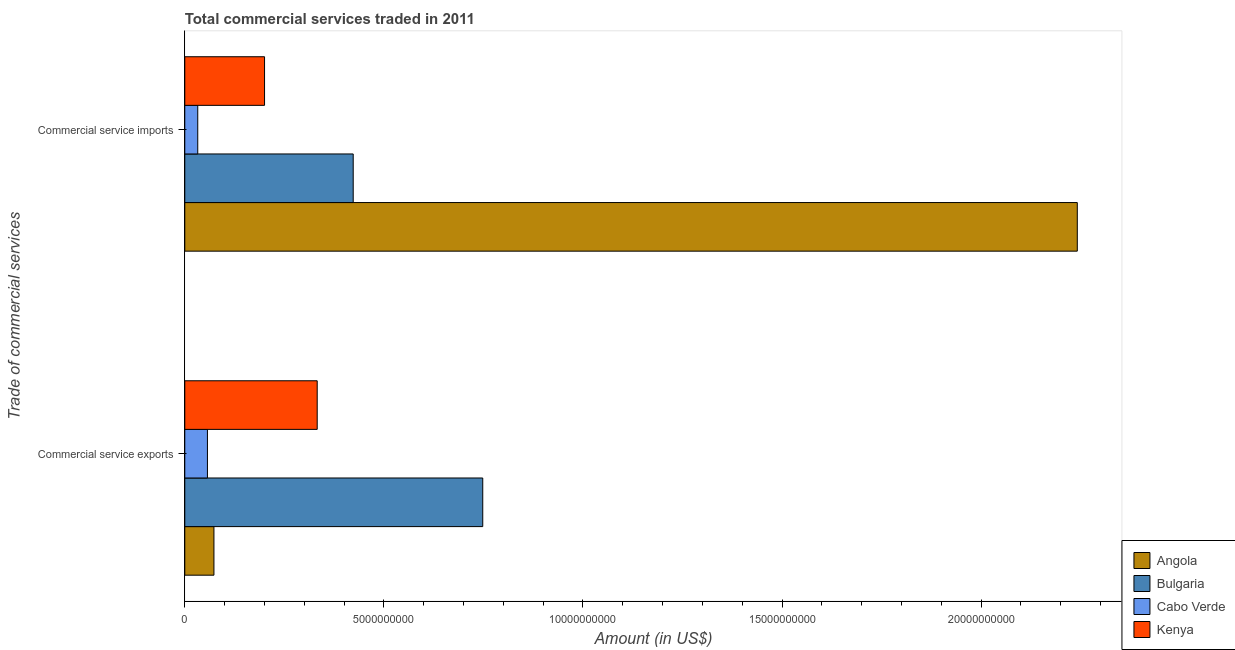Are the number of bars per tick equal to the number of legend labels?
Offer a very short reply. Yes. Are the number of bars on each tick of the Y-axis equal?
Ensure brevity in your answer.  Yes. How many bars are there on the 1st tick from the top?
Offer a very short reply. 4. How many bars are there on the 2nd tick from the bottom?
Ensure brevity in your answer.  4. What is the label of the 1st group of bars from the top?
Offer a very short reply. Commercial service imports. What is the amount of commercial service imports in Angola?
Provide a short and direct response. 2.24e+1. Across all countries, what is the maximum amount of commercial service imports?
Offer a very short reply. 2.24e+1. Across all countries, what is the minimum amount of commercial service imports?
Your answer should be compact. 3.26e+08. In which country was the amount of commercial service imports minimum?
Provide a succinct answer. Cabo Verde. What is the total amount of commercial service imports in the graph?
Keep it short and to the point. 2.90e+1. What is the difference between the amount of commercial service imports in Cabo Verde and that in Kenya?
Provide a short and direct response. -1.68e+09. What is the difference between the amount of commercial service imports in Angola and the amount of commercial service exports in Kenya?
Keep it short and to the point. 1.91e+1. What is the average amount of commercial service imports per country?
Your response must be concise. 7.24e+09. What is the difference between the amount of commercial service imports and amount of commercial service exports in Bulgaria?
Your response must be concise. -3.25e+09. What is the ratio of the amount of commercial service imports in Cabo Verde to that in Angola?
Provide a succinct answer. 0.01. In how many countries, is the amount of commercial service imports greater than the average amount of commercial service imports taken over all countries?
Provide a short and direct response. 1. What does the 4th bar from the top in Commercial service imports represents?
Make the answer very short. Angola. What does the 4th bar from the bottom in Commercial service imports represents?
Your answer should be very brief. Kenya. How many bars are there?
Your answer should be very brief. 8. Are all the bars in the graph horizontal?
Offer a terse response. Yes. What is the difference between two consecutive major ticks on the X-axis?
Make the answer very short. 5.00e+09. Where does the legend appear in the graph?
Give a very brief answer. Bottom right. What is the title of the graph?
Ensure brevity in your answer.  Total commercial services traded in 2011. Does "Uruguay" appear as one of the legend labels in the graph?
Provide a succinct answer. No. What is the label or title of the Y-axis?
Provide a succinct answer. Trade of commercial services. What is the Amount (in US$) of Angola in Commercial service exports?
Offer a terse response. 7.32e+08. What is the Amount (in US$) in Bulgaria in Commercial service exports?
Make the answer very short. 7.48e+09. What is the Amount (in US$) of Cabo Verde in Commercial service exports?
Offer a terse response. 5.69e+08. What is the Amount (in US$) of Kenya in Commercial service exports?
Keep it short and to the point. 3.33e+09. What is the Amount (in US$) in Angola in Commercial service imports?
Your response must be concise. 2.24e+1. What is the Amount (in US$) in Bulgaria in Commercial service imports?
Give a very brief answer. 4.23e+09. What is the Amount (in US$) in Cabo Verde in Commercial service imports?
Offer a very short reply. 3.26e+08. What is the Amount (in US$) of Kenya in Commercial service imports?
Keep it short and to the point. 2.00e+09. Across all Trade of commercial services, what is the maximum Amount (in US$) in Angola?
Keep it short and to the point. 2.24e+1. Across all Trade of commercial services, what is the maximum Amount (in US$) of Bulgaria?
Your response must be concise. 7.48e+09. Across all Trade of commercial services, what is the maximum Amount (in US$) of Cabo Verde?
Provide a succinct answer. 5.69e+08. Across all Trade of commercial services, what is the maximum Amount (in US$) in Kenya?
Provide a short and direct response. 3.33e+09. Across all Trade of commercial services, what is the minimum Amount (in US$) in Angola?
Your answer should be compact. 7.32e+08. Across all Trade of commercial services, what is the minimum Amount (in US$) of Bulgaria?
Your response must be concise. 4.23e+09. Across all Trade of commercial services, what is the minimum Amount (in US$) of Cabo Verde?
Provide a short and direct response. 3.26e+08. Across all Trade of commercial services, what is the minimum Amount (in US$) of Kenya?
Keep it short and to the point. 2.00e+09. What is the total Amount (in US$) of Angola in the graph?
Your answer should be compact. 2.31e+1. What is the total Amount (in US$) of Bulgaria in the graph?
Your answer should be very brief. 1.17e+1. What is the total Amount (in US$) of Cabo Verde in the graph?
Ensure brevity in your answer.  8.95e+08. What is the total Amount (in US$) in Kenya in the graph?
Ensure brevity in your answer.  5.33e+09. What is the difference between the Amount (in US$) of Angola in Commercial service exports and that in Commercial service imports?
Your response must be concise. -2.17e+1. What is the difference between the Amount (in US$) in Bulgaria in Commercial service exports and that in Commercial service imports?
Ensure brevity in your answer.  3.25e+09. What is the difference between the Amount (in US$) in Cabo Verde in Commercial service exports and that in Commercial service imports?
Your answer should be very brief. 2.43e+08. What is the difference between the Amount (in US$) in Kenya in Commercial service exports and that in Commercial service imports?
Give a very brief answer. 1.32e+09. What is the difference between the Amount (in US$) of Angola in Commercial service exports and the Amount (in US$) of Bulgaria in Commercial service imports?
Ensure brevity in your answer.  -3.50e+09. What is the difference between the Amount (in US$) of Angola in Commercial service exports and the Amount (in US$) of Cabo Verde in Commercial service imports?
Provide a succinct answer. 4.07e+08. What is the difference between the Amount (in US$) of Angola in Commercial service exports and the Amount (in US$) of Kenya in Commercial service imports?
Your answer should be compact. -1.27e+09. What is the difference between the Amount (in US$) in Bulgaria in Commercial service exports and the Amount (in US$) in Cabo Verde in Commercial service imports?
Offer a very short reply. 7.16e+09. What is the difference between the Amount (in US$) in Bulgaria in Commercial service exports and the Amount (in US$) in Kenya in Commercial service imports?
Give a very brief answer. 5.48e+09. What is the difference between the Amount (in US$) of Cabo Verde in Commercial service exports and the Amount (in US$) of Kenya in Commercial service imports?
Keep it short and to the point. -1.43e+09. What is the average Amount (in US$) of Angola per Trade of commercial services?
Provide a succinct answer. 1.16e+1. What is the average Amount (in US$) of Bulgaria per Trade of commercial services?
Your response must be concise. 5.86e+09. What is the average Amount (in US$) of Cabo Verde per Trade of commercial services?
Offer a very short reply. 4.47e+08. What is the average Amount (in US$) in Kenya per Trade of commercial services?
Your answer should be compact. 2.66e+09. What is the difference between the Amount (in US$) in Angola and Amount (in US$) in Bulgaria in Commercial service exports?
Offer a very short reply. -6.75e+09. What is the difference between the Amount (in US$) of Angola and Amount (in US$) of Cabo Verde in Commercial service exports?
Offer a very short reply. 1.63e+08. What is the difference between the Amount (in US$) in Angola and Amount (in US$) in Kenya in Commercial service exports?
Your answer should be compact. -2.59e+09. What is the difference between the Amount (in US$) of Bulgaria and Amount (in US$) of Cabo Verde in Commercial service exports?
Ensure brevity in your answer.  6.91e+09. What is the difference between the Amount (in US$) in Bulgaria and Amount (in US$) in Kenya in Commercial service exports?
Offer a terse response. 4.16e+09. What is the difference between the Amount (in US$) in Cabo Verde and Amount (in US$) in Kenya in Commercial service exports?
Provide a succinct answer. -2.76e+09. What is the difference between the Amount (in US$) in Angola and Amount (in US$) in Bulgaria in Commercial service imports?
Provide a succinct answer. 1.82e+1. What is the difference between the Amount (in US$) of Angola and Amount (in US$) of Cabo Verde in Commercial service imports?
Give a very brief answer. 2.21e+1. What is the difference between the Amount (in US$) of Angola and Amount (in US$) of Kenya in Commercial service imports?
Provide a short and direct response. 2.04e+1. What is the difference between the Amount (in US$) of Bulgaria and Amount (in US$) of Cabo Verde in Commercial service imports?
Provide a succinct answer. 3.90e+09. What is the difference between the Amount (in US$) in Bulgaria and Amount (in US$) in Kenya in Commercial service imports?
Your response must be concise. 2.23e+09. What is the difference between the Amount (in US$) in Cabo Verde and Amount (in US$) in Kenya in Commercial service imports?
Give a very brief answer. -1.68e+09. What is the ratio of the Amount (in US$) in Angola in Commercial service exports to that in Commercial service imports?
Ensure brevity in your answer.  0.03. What is the ratio of the Amount (in US$) in Bulgaria in Commercial service exports to that in Commercial service imports?
Provide a succinct answer. 1.77. What is the ratio of the Amount (in US$) of Cabo Verde in Commercial service exports to that in Commercial service imports?
Your response must be concise. 1.75. What is the ratio of the Amount (in US$) in Kenya in Commercial service exports to that in Commercial service imports?
Keep it short and to the point. 1.66. What is the difference between the highest and the second highest Amount (in US$) in Angola?
Provide a short and direct response. 2.17e+1. What is the difference between the highest and the second highest Amount (in US$) in Bulgaria?
Make the answer very short. 3.25e+09. What is the difference between the highest and the second highest Amount (in US$) in Cabo Verde?
Offer a terse response. 2.43e+08. What is the difference between the highest and the second highest Amount (in US$) in Kenya?
Your response must be concise. 1.32e+09. What is the difference between the highest and the lowest Amount (in US$) in Angola?
Offer a very short reply. 2.17e+1. What is the difference between the highest and the lowest Amount (in US$) in Bulgaria?
Provide a succinct answer. 3.25e+09. What is the difference between the highest and the lowest Amount (in US$) of Cabo Verde?
Give a very brief answer. 2.43e+08. What is the difference between the highest and the lowest Amount (in US$) of Kenya?
Your response must be concise. 1.32e+09. 